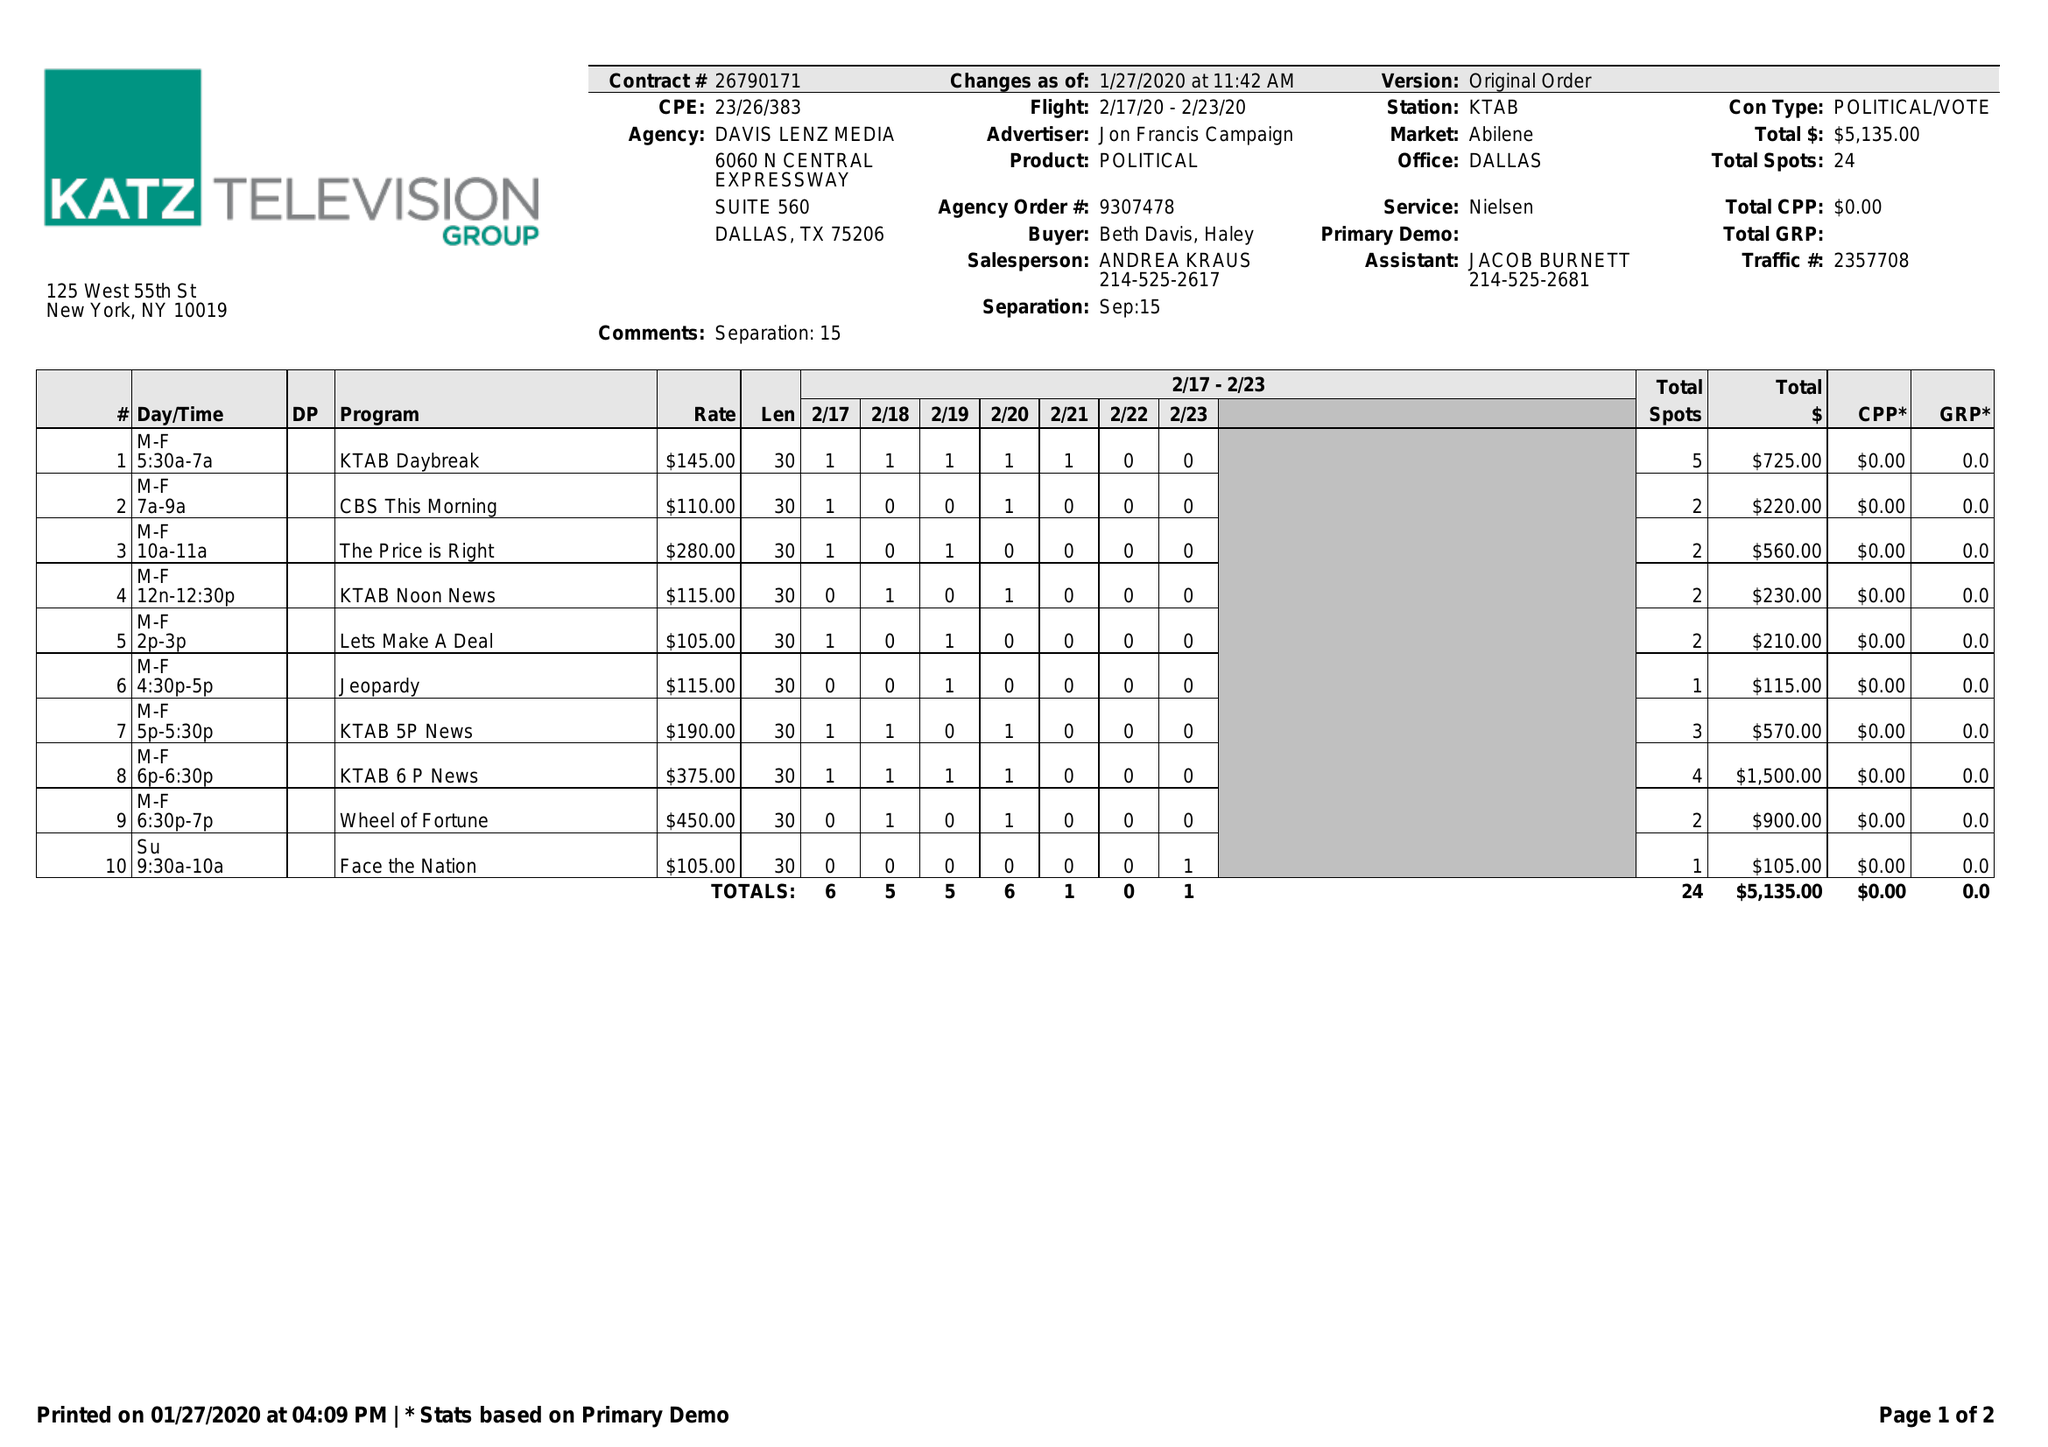What is the value for the contract_num?
Answer the question using a single word or phrase. 26790171 